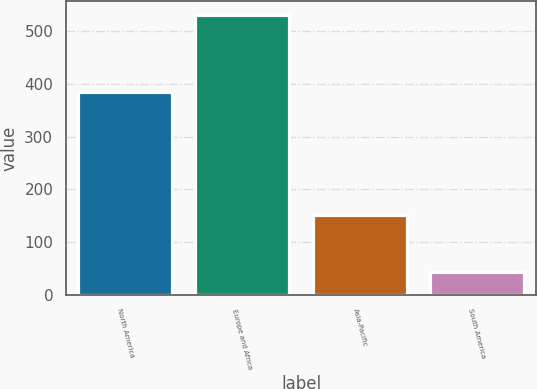Convert chart. <chart><loc_0><loc_0><loc_500><loc_500><bar_chart><fcel>North America<fcel>Europe and Africa<fcel>Asia-Pacific<fcel>South America<nl><fcel>384<fcel>530<fcel>152<fcel>43<nl></chart> 